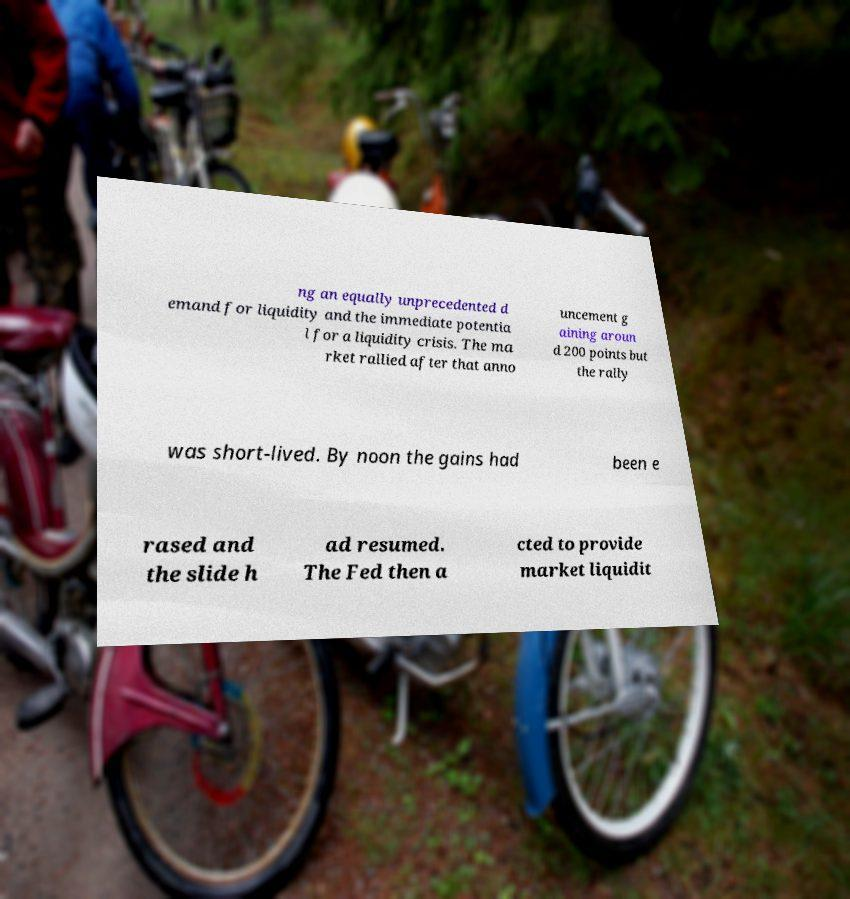What messages or text are displayed in this image? I need them in a readable, typed format. ng an equally unprecedented d emand for liquidity and the immediate potentia l for a liquidity crisis. The ma rket rallied after that anno uncement g aining aroun d 200 points but the rally was short-lived. By noon the gains had been e rased and the slide h ad resumed. The Fed then a cted to provide market liquidit 